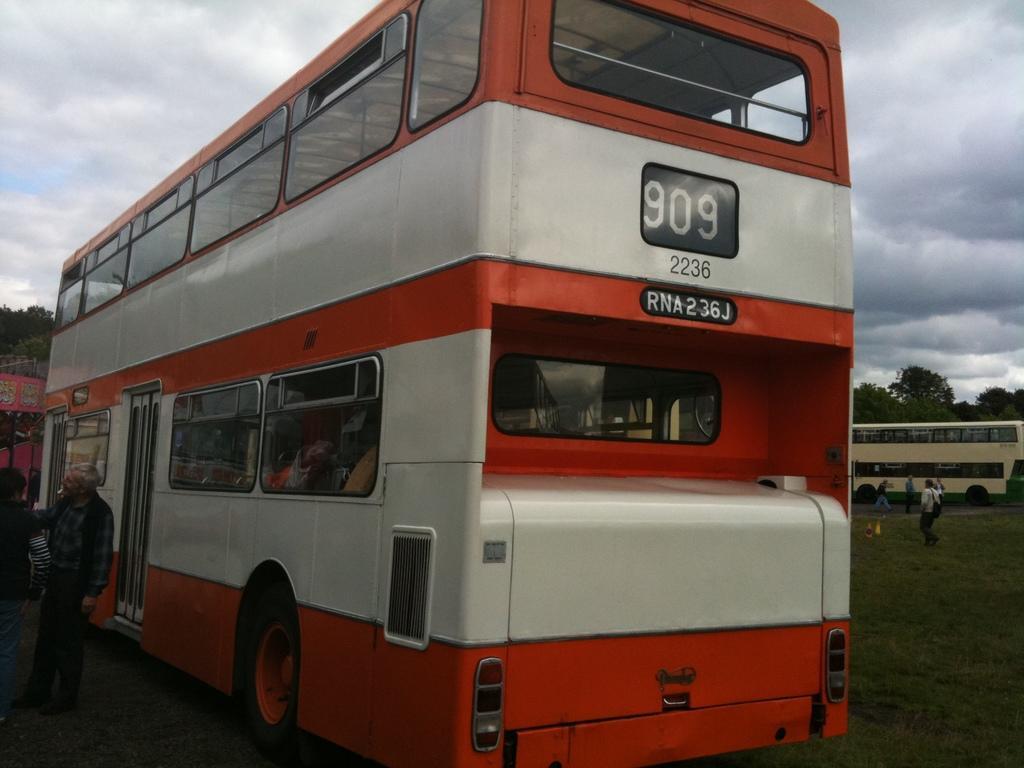Can you describe this image briefly? In the middle of the picture, we see a double decker bus in red and white color. Beside that, we see two men are standing. Behind them, we see a stall. On the right side, we see people are walking on the road. Behind them, we see a double decker bus in white and green color. There are trees in the background. At the top of the picture, we see the sky. 